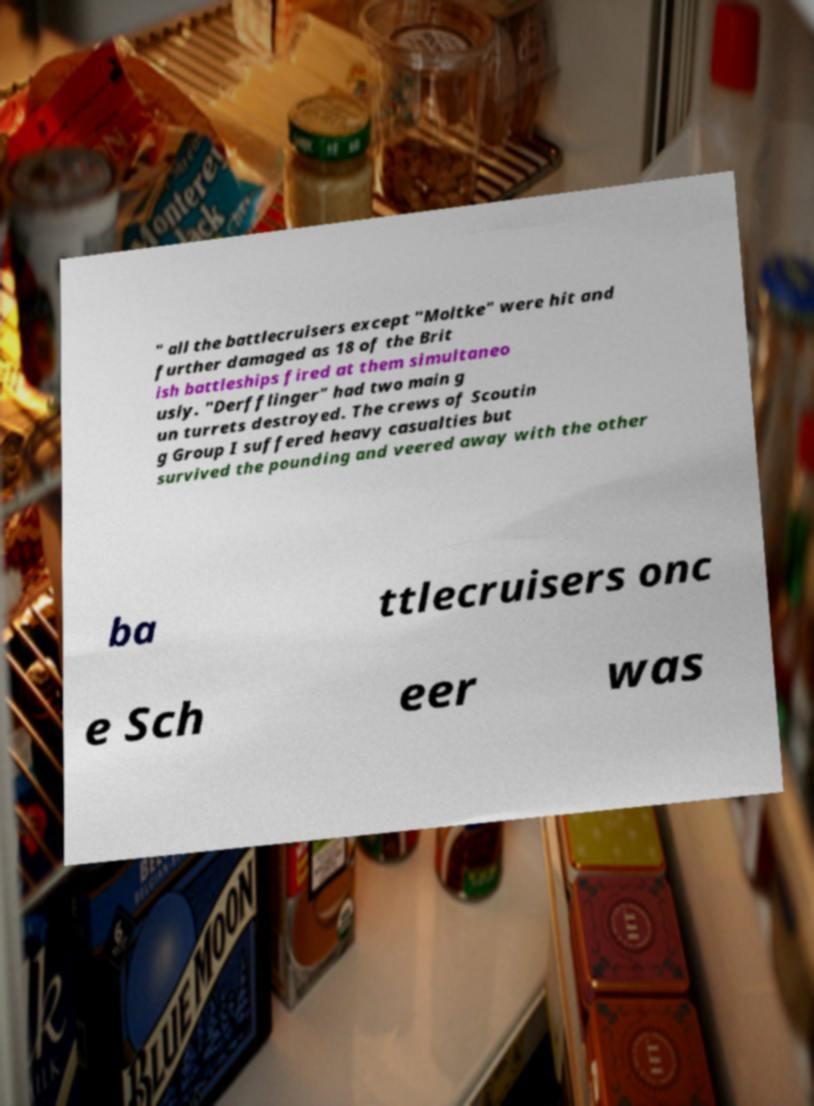For documentation purposes, I need the text within this image transcribed. Could you provide that? " all the battlecruisers except "Moltke" were hit and further damaged as 18 of the Brit ish battleships fired at them simultaneo usly. "Derfflinger" had two main g un turrets destroyed. The crews of Scoutin g Group I suffered heavy casualties but survived the pounding and veered away with the other ba ttlecruisers onc e Sch eer was 